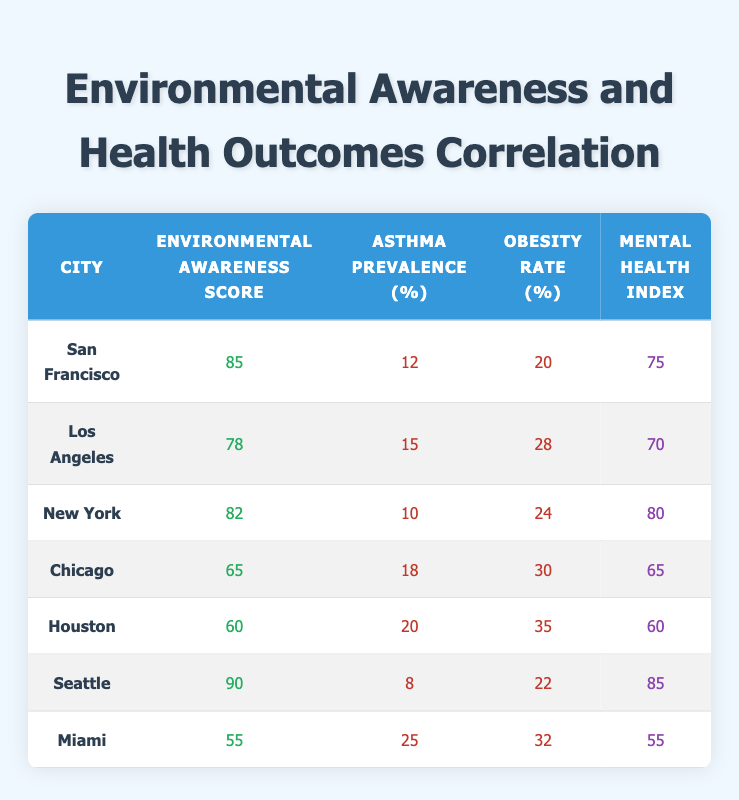What is the environmental awareness score of Seattle? The table lists Seattle with an environmental awareness score of 90 in the second column.
Answer: 90 Which city has the highest obesity rate according to the table? In the obesity rate column, Houston has the highest rate at 35%.
Answer: Houston What is the average asthma prevalence of the cities? The asthma prevalence values are 12, 15, 10, 18, 20, 8, and 25. Summing these gives 108, and then averaging by dividing by 7 results in approximately 15.43.
Answer: 15.43 Is there a correlation between a higher environmental awareness score and a lower asthma prevalence in the cities listed? The cities with higher environmental awareness scores, like Seattle and San Francisco, also tend to have lower asthma prevalence, indicating a possible correlation.
Answer: Yes What is the sum of obesity rates for cities with an environmental awareness score above 80? The cities with scores above 80 are San Francisco (20), New York (24), and Seattle (22). Adding these gives 20 + 24 + 22 = 66.
Answer: 66 Which city has the lowest mental health index? The mental health index values are 75, 70, 80, 65, 60, 85, and 55. Miami has the lowest at 55.
Answer: Miami Is the asthma prevalence in Houston higher than that in Los Angeles? Houston's asthma prevalence is 20%, which is higher than Los Angeles' prevalence of 15%.
Answer: Yes What is the difference in mental health index between Seattle and Chicago? Seattle’s mental health index is 85 and Chicago's is 65. The difference is 85 - 65 = 20.
Answer: 20 Which city has the second highest environmental awareness score? The scores in order are 90 (Seattle), 85 (San Francisco), 82 (New York), 78 (Los Angeles), and so on. San Francisco has the second highest score of 85.
Answer: San Francisco 